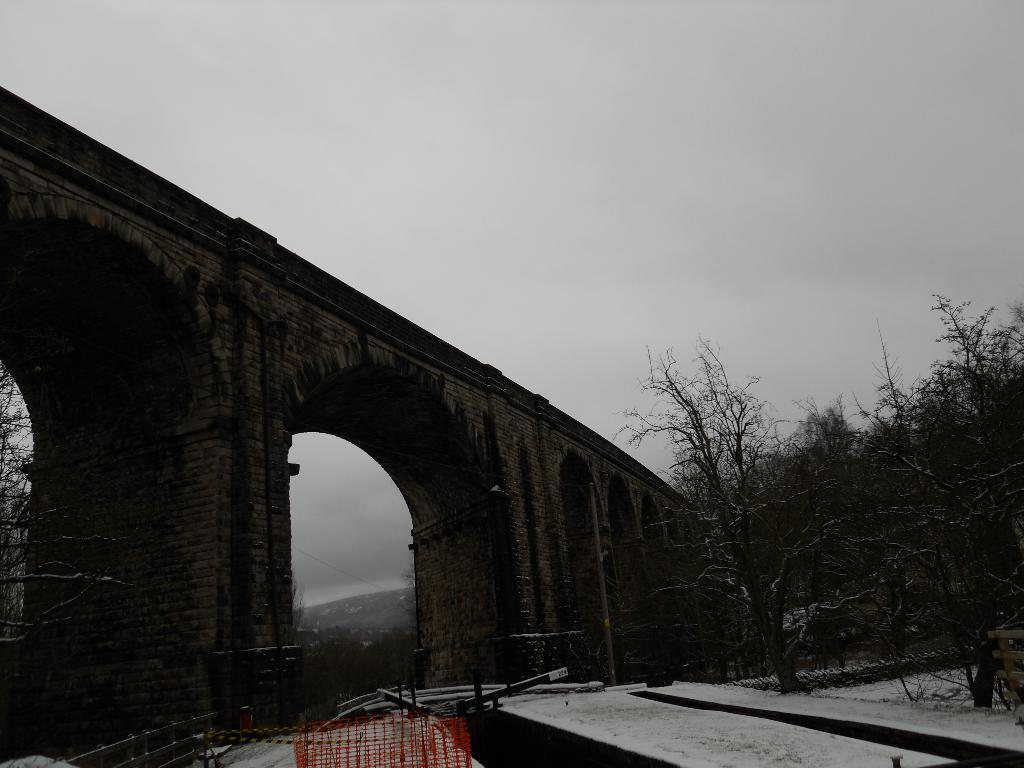What type of structure can be seen in the image? There is a bridge in the image. What architectural feature is present in the image? There is an arch in the image. What type of vegetation is visible in the image? There are trees in the image. What weather condition is depicted in the image? There is snow in the image. What type of barrier can be seen in the image? There is a fence in the image. What is the condition of the sky in the image? The sky is cloudy in the image. Where is the jar located in the image? There is no jar present in the image. Can you describe the seashore in the image? There is no seashore present in the image; it features a bridge, trees, and snow. What type of clothing has a zipper in the image? There is no clothing or zipper present in the image. 